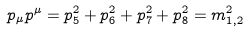Convert formula to latex. <formula><loc_0><loc_0><loc_500><loc_500>p _ { \mu } p ^ { \mu } = p ^ { 2 } _ { 5 } + p _ { 6 } ^ { 2 } + p _ { 7 } ^ { 2 } + p _ { 8 } ^ { 2 } = m _ { 1 , 2 } ^ { 2 }</formula> 